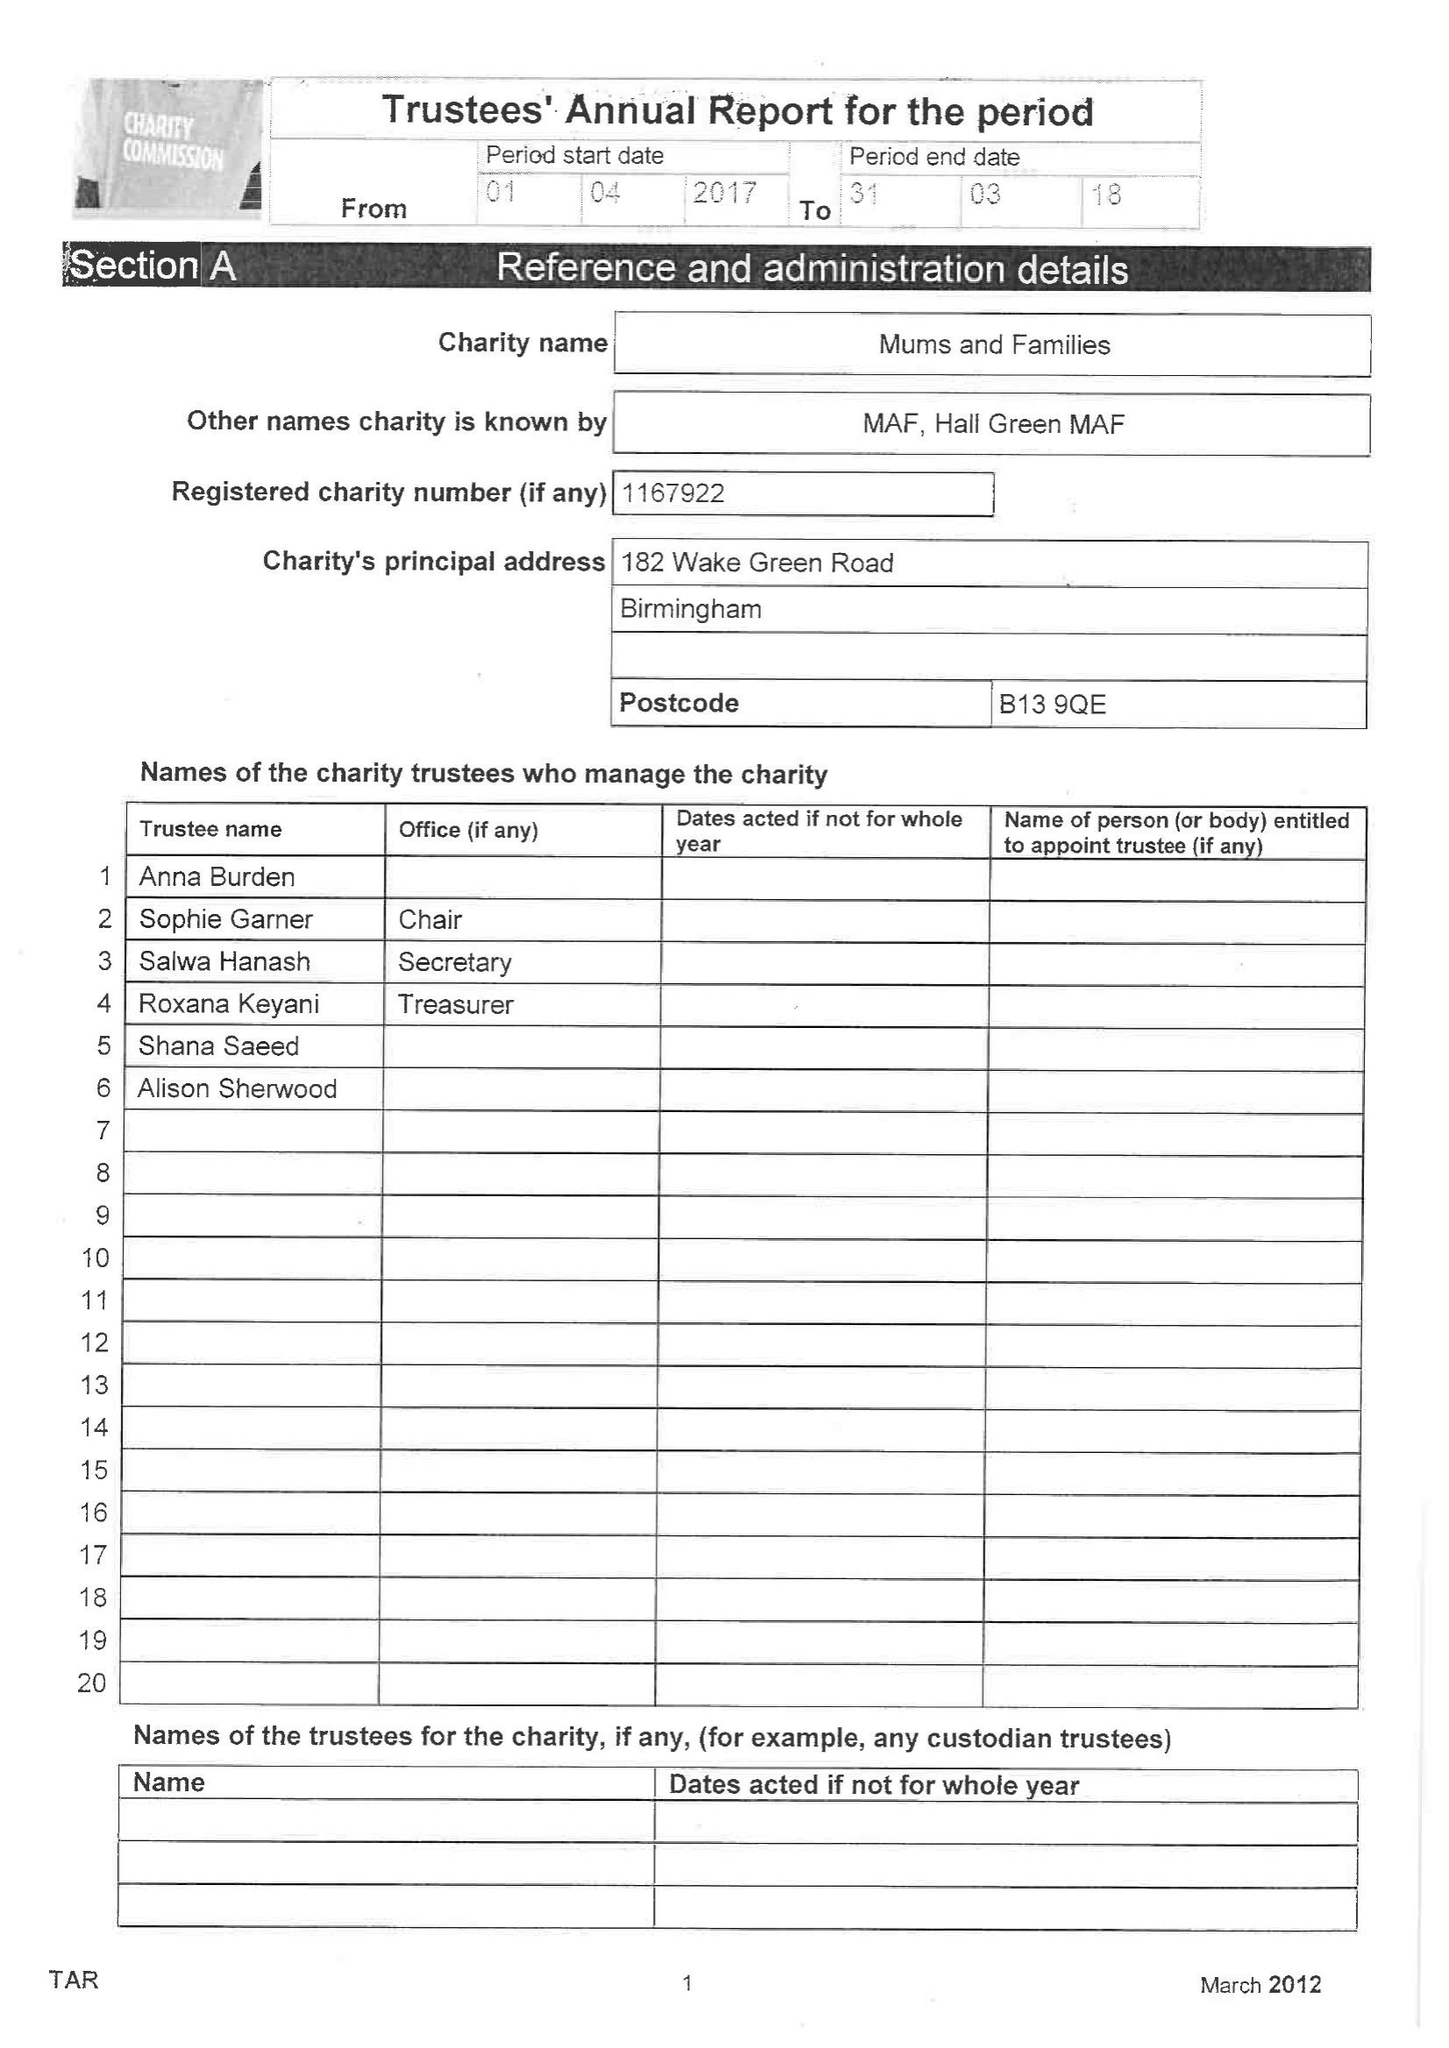What is the value for the spending_annually_in_british_pounds?
Answer the question using a single word or phrase. 826.00 